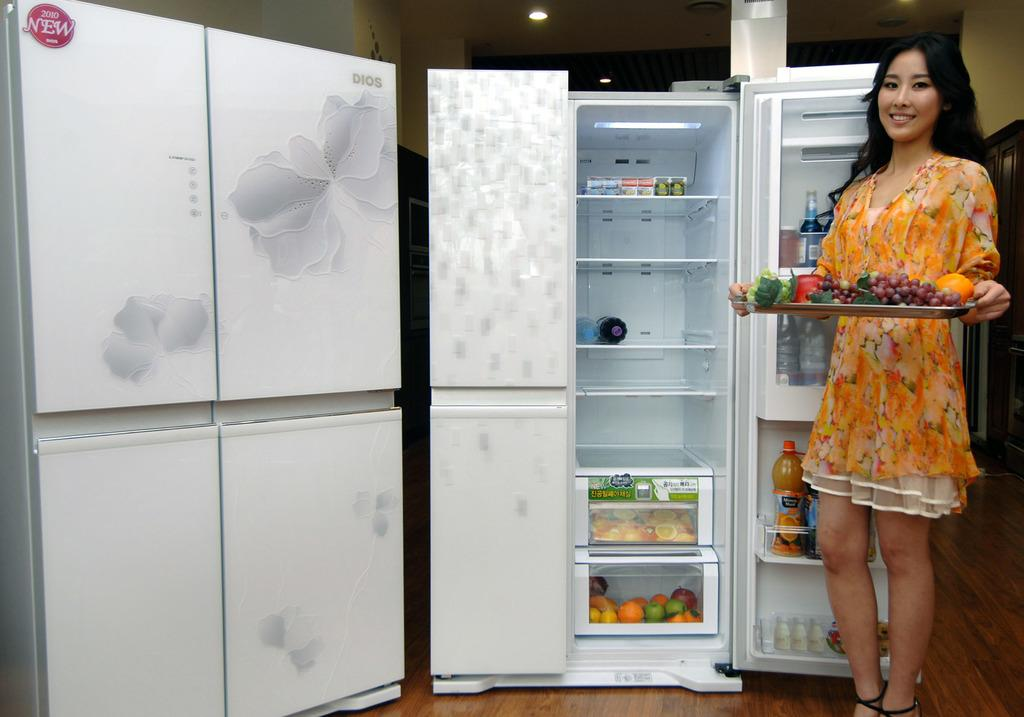<image>
Describe the image concisely. A white fridge that has a 2010 new sticker on it. 